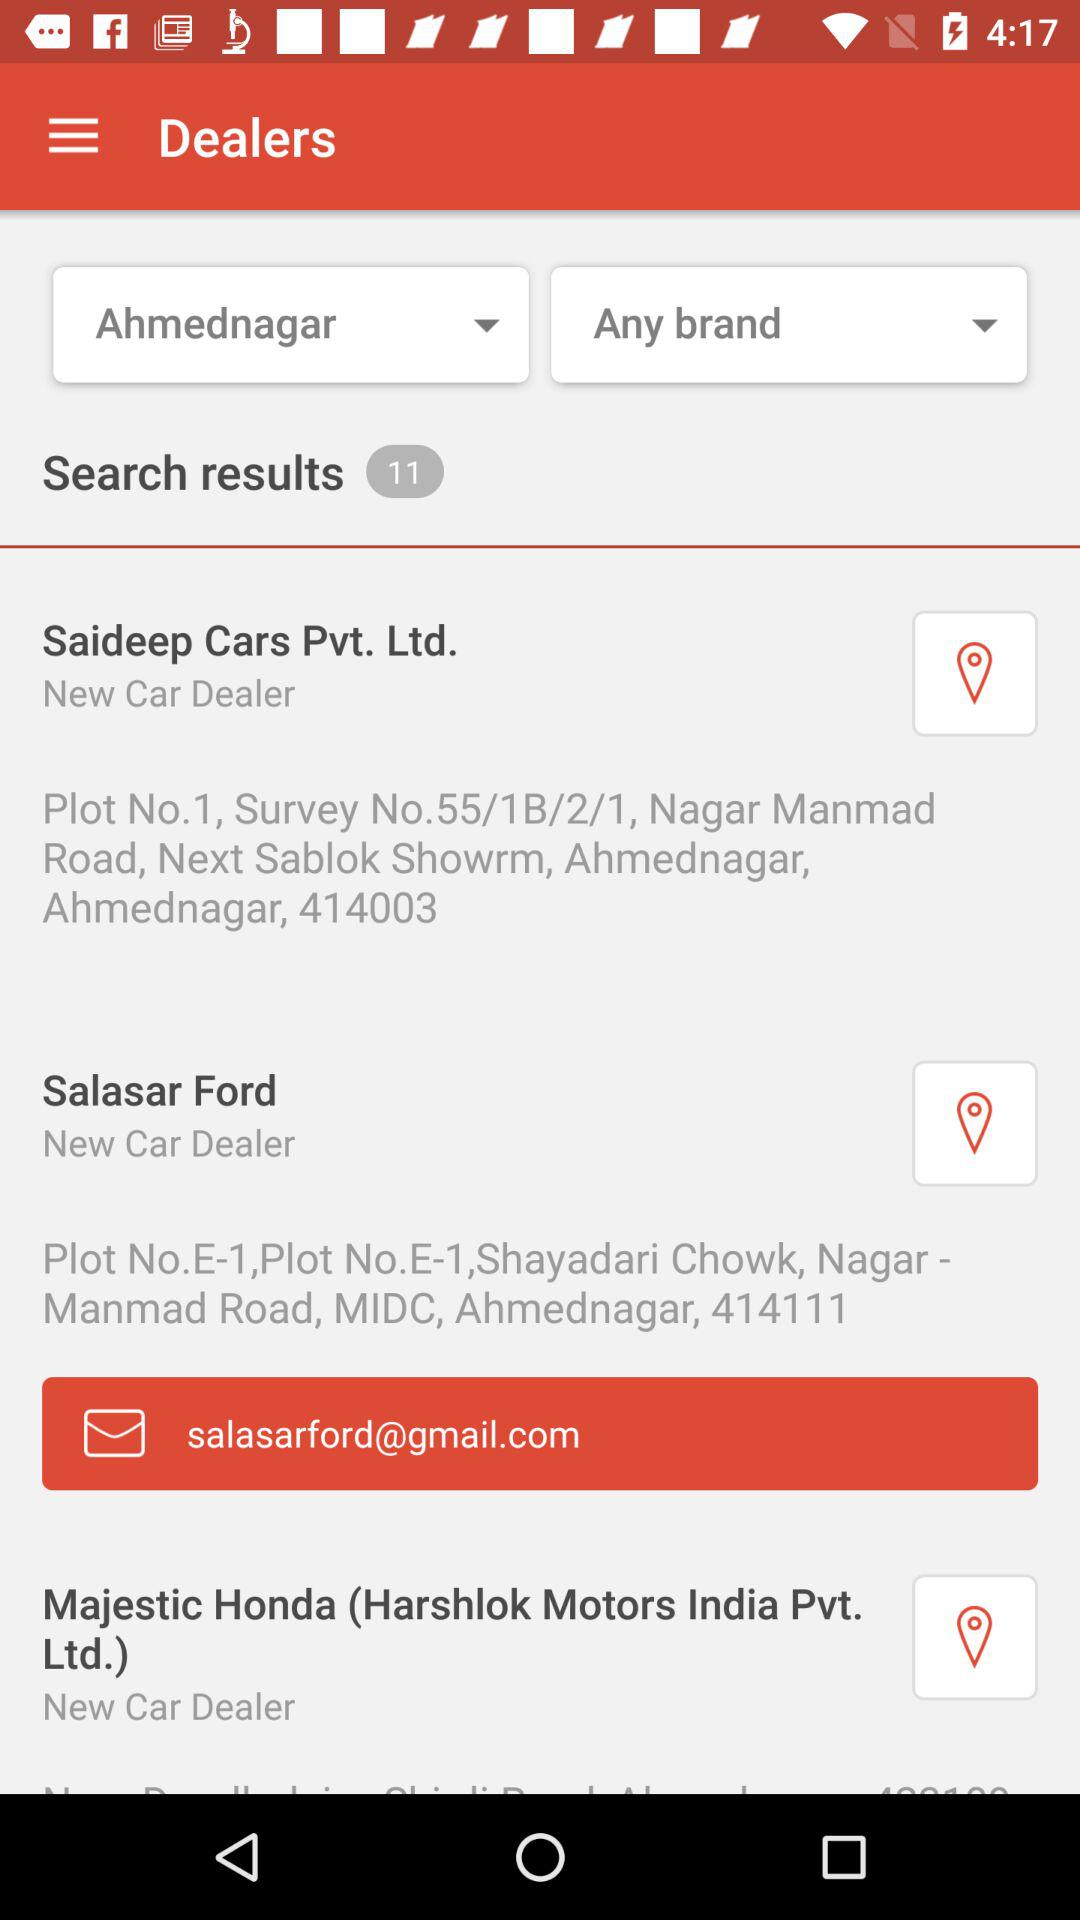How many dealers are in Ahmednagar?
Answer the question using a single word or phrase. 11 